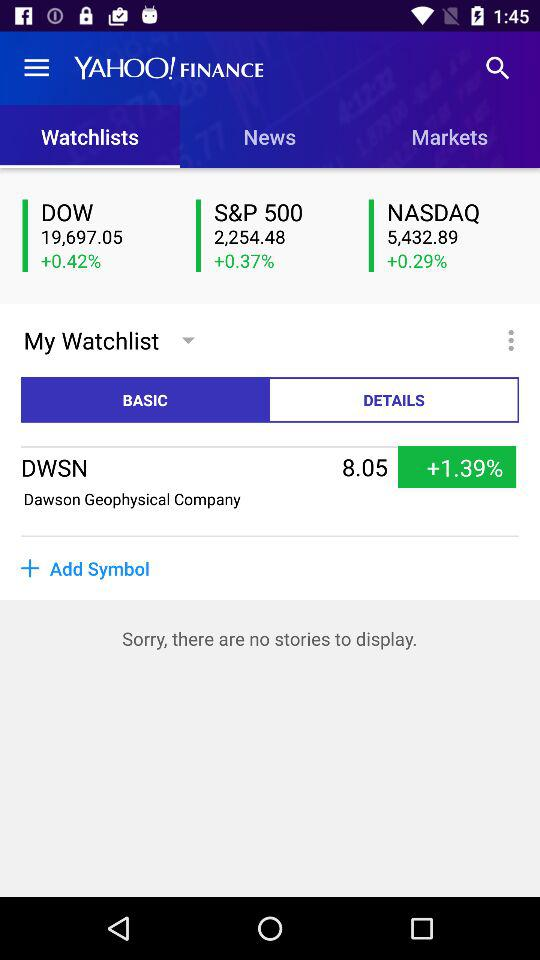Which tab is selected? The selected tabs are "Watchlists" and "BASIC". 